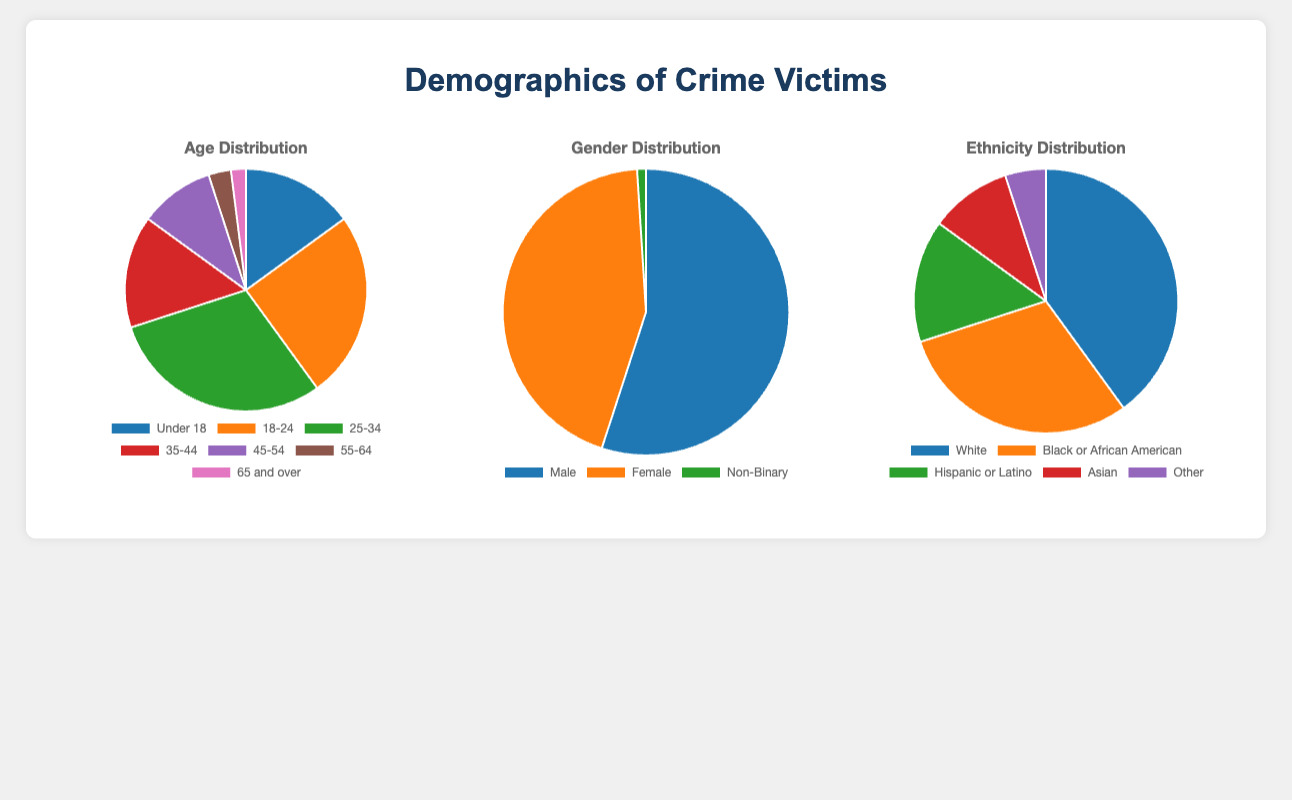What age group has the highest number of crime victims? The chart shows different age groups and their corresponding percentage of victims. By comparing the slices, the 25-34 age group has the largest slice, indicating the highest number of crime victims.
Answer: 25-34 Which gender has the lowest representation among crime victims? The gender distribution chart shows the slices for Male, Female, and Non-Binary. The Non-Binary slice is the smallest, indicating the lowest representation.
Answer: Non-Binary What is the combined percentage of crime victims aged 18-24 and 25-34? Sum the percentages of the 18-24 and 25-34 age groups. From the chart, 18-24 is 25% and 25-34 is 30%. So, 25% + 30% = 55%.
Answer: 55% How does the percentage of female crime victims compare to male crime victims? The Gender Distribution chart shows slices for Male and Female. The Male slice is slightly larger than the Female slice, indicating a higher percentage of male victims compared to female victims.
Answer: Male > Female Among crime victims, which ethnicity has the second-highest representation? The chart for Ethnicity Distribution shows slices for different ethnic groups. The largest slice represents White (first), and the second-largest slice represents Black or African American.
Answer: Black or African American What percentage of crime victims are 45 years and older? Sum the percentages of the age groups 45-54, 55-64, and 65 and over. From the chart: 45-54 is 10%, 55-64 is 3%, and 65 and over is 2%. So, 10% + 3% + 2% = 15%.
Answer: 15% Which age group has the same number of crime victims as the entire Non-Binary group? The Non-Binary group has 1 crime victim. Looking at the Age Distribution chart, the 55-64 and 65 and over age groups have more than 1 victim, but none have exactly 1. Therefore, none match exactly.
Answer: None What is the difference in the number of crime victims between the 18-24 and 45-54 age groups? Subtract the victims in the 45-54 group from the 18-24 group. 18-24 has 25 victims, and 45-54 has 10 victims. So, 25 - 10 = 15.
Answer: 15 Which ethnic group has the smallest representation among crime victims and what is their percentage? The Ethnicity Distribution chart shows slices for various ethnic groups. The smallest slice represents the 'Other' group.
Answer: Other 